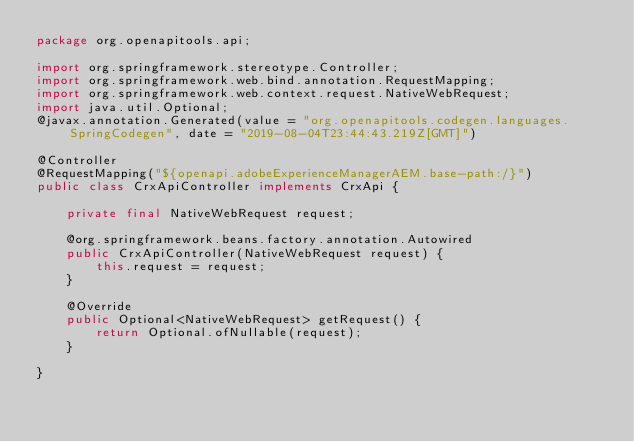<code> <loc_0><loc_0><loc_500><loc_500><_Java_>package org.openapitools.api;

import org.springframework.stereotype.Controller;
import org.springframework.web.bind.annotation.RequestMapping;
import org.springframework.web.context.request.NativeWebRequest;
import java.util.Optional;
@javax.annotation.Generated(value = "org.openapitools.codegen.languages.SpringCodegen", date = "2019-08-04T23:44:43.219Z[GMT]")

@Controller
@RequestMapping("${openapi.adobeExperienceManagerAEM.base-path:/}")
public class CrxApiController implements CrxApi {

    private final NativeWebRequest request;

    @org.springframework.beans.factory.annotation.Autowired
    public CrxApiController(NativeWebRequest request) {
        this.request = request;
    }

    @Override
    public Optional<NativeWebRequest> getRequest() {
        return Optional.ofNullable(request);
    }

}
</code> 